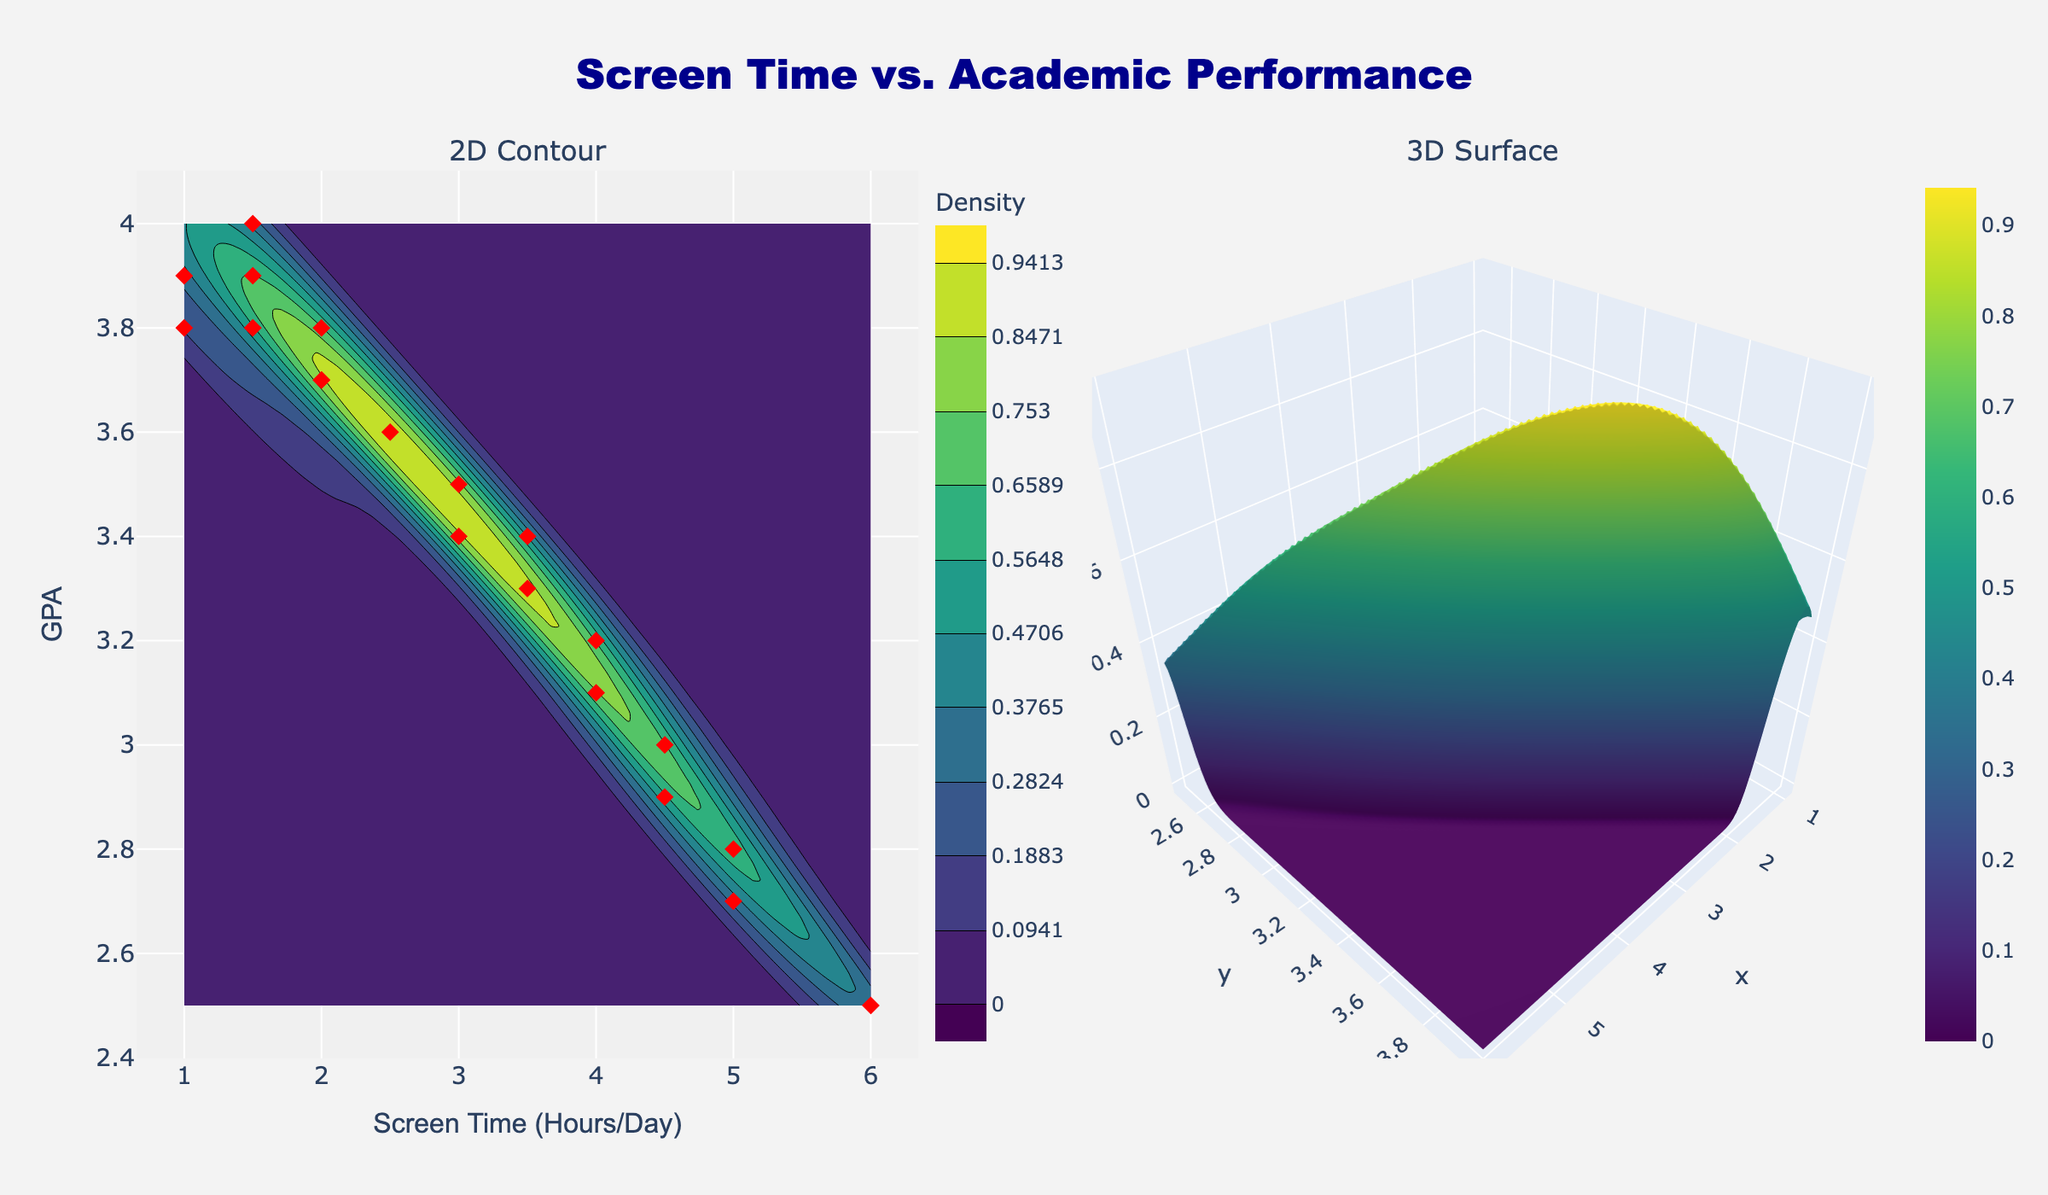What's the title of the figure? The title of a plot is usually prominently displayed at the top. In this case, it reads "Screen Time vs. Academic Performance".
Answer: Screen Time vs. Academic Performance What is the range of values on the x-axis in the 2D contour plot? By looking at the axis labels and tick marks, one can determine the range. The x-axis, which represents Screen Time (Hours/Day), ranges from 1 to 6 hours per day.
Answer: 1 to 6 How many students have a GPA of 4.0? Observing the red diamond markers, we count how many align with the GPA value of 4.0. There is only one red diamond at this position.
Answer: 1 What color scale is used in the contour plots? The color scale used can be deduced from the color bar and overall appearance of the plot. Here, it uses shades of green, blue, and yellow, which is characteristic of the Viridis color scale.
Answer: Viridis Which student has the highest screen time, and what is their GPA? By observing the scatter plot, it can be seen which red diamond marker is farthest to the right on the x-axis. It corresponds to Lucas with a screen time of 6 hours per day and a GPA of 2.5.
Answer: Lucas, 2.5 What is the general trend between screen time and GPA in the 2D contour plot? Examining the overall density and scatter plot, a negative trend can be observed; as screen time increases, GPA generally decreases.
Answer: Negative trend Which two students have the same screen time but different GPAs? By closely inspecting the scatter plot, two red diamonds aligned along the same x-axis value but differing in their y-axis values are identified. Alice and Sophia both have 2 hours per day screen time but GPAs of 3.7 and 3.8 respectively.
Answer: Alice and Sophia Which area on the 2D contour plot has the highest density of students? The highest density area can be identified by the darkest shades of the Viridis color scale, concentrated where the screen time is between 1.5 and 3.5 hours/day and GPA is between 3.4 and 3.9.
Answer: Screen time 1.5 to 3.5 hours/day, GPA 3.4 to 3.9 How does the density of students change as screen time increases from 1 hour to 6 hours per day? By interpreting the contours from left to right, it is observed that density decreases; the darkest areas (highest density) are on the left side of the plot, indicating lower screen time has higher student density.
Answer: Decreases What is the GPA range where screen time has the least density of students? By identifying the lightest areas on the 2D contour plot, it can be observed that screen time around 5-6 hours/day corresponds to the GPA range of approximately 2.5 to 3.0, having the least student density.
Answer: 2.5 to 3.0 